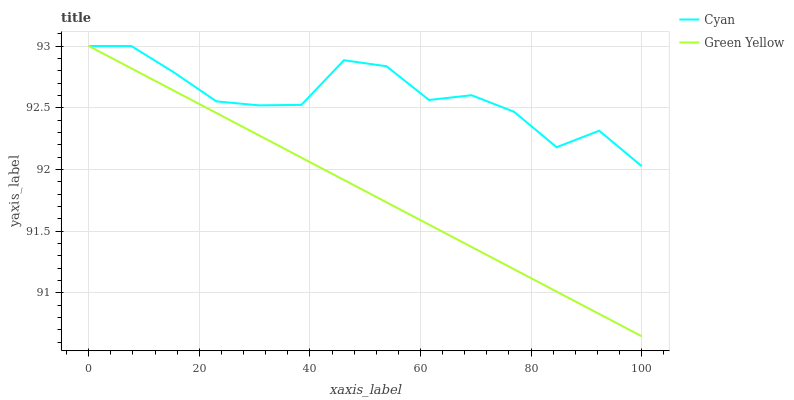Does Green Yellow have the minimum area under the curve?
Answer yes or no. Yes. Does Cyan have the maximum area under the curve?
Answer yes or no. Yes. Does Green Yellow have the maximum area under the curve?
Answer yes or no. No. Is Green Yellow the smoothest?
Answer yes or no. Yes. Is Cyan the roughest?
Answer yes or no. Yes. Is Green Yellow the roughest?
Answer yes or no. No. Does Green Yellow have the lowest value?
Answer yes or no. Yes. Does Green Yellow have the highest value?
Answer yes or no. Yes. Does Cyan intersect Green Yellow?
Answer yes or no. Yes. Is Cyan less than Green Yellow?
Answer yes or no. No. Is Cyan greater than Green Yellow?
Answer yes or no. No. 